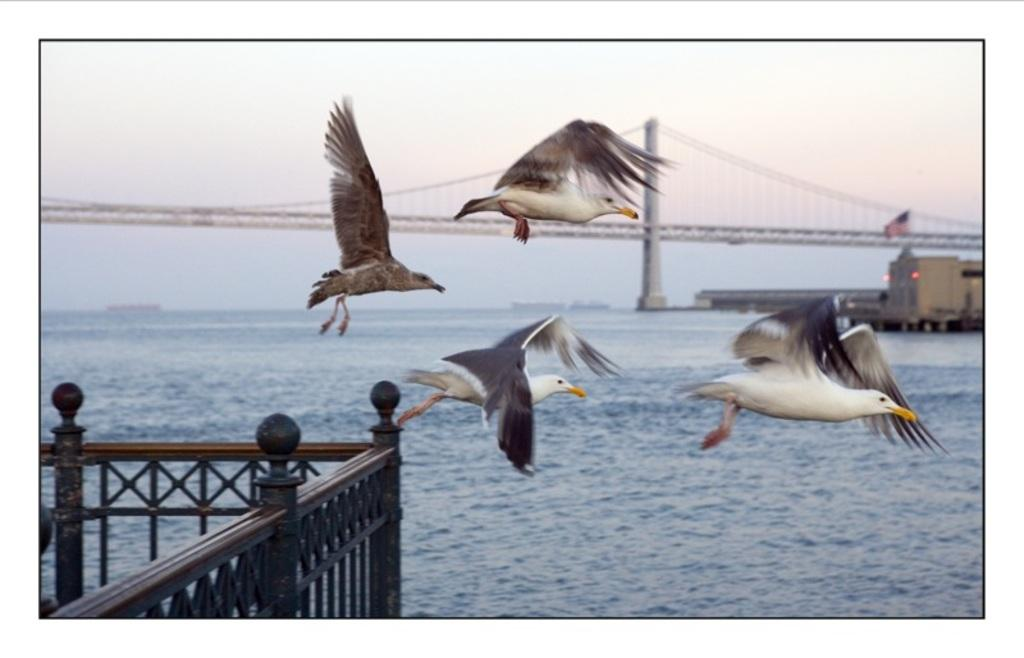What type of animals can be seen in the image? There are white color birds in the image. What are the birds doing in the image? The birds are flying in the air. What can be seen in the background of the image? There is a fence, water, and the sky visible in the background of the image. What year is depicted in the image? The image does not depict a specific year; it is a timeless scene of birds flying. What type of tail is visible on the birds in the image? The image does not show the tails of the birds, as they are flying and the tails are not visible. 